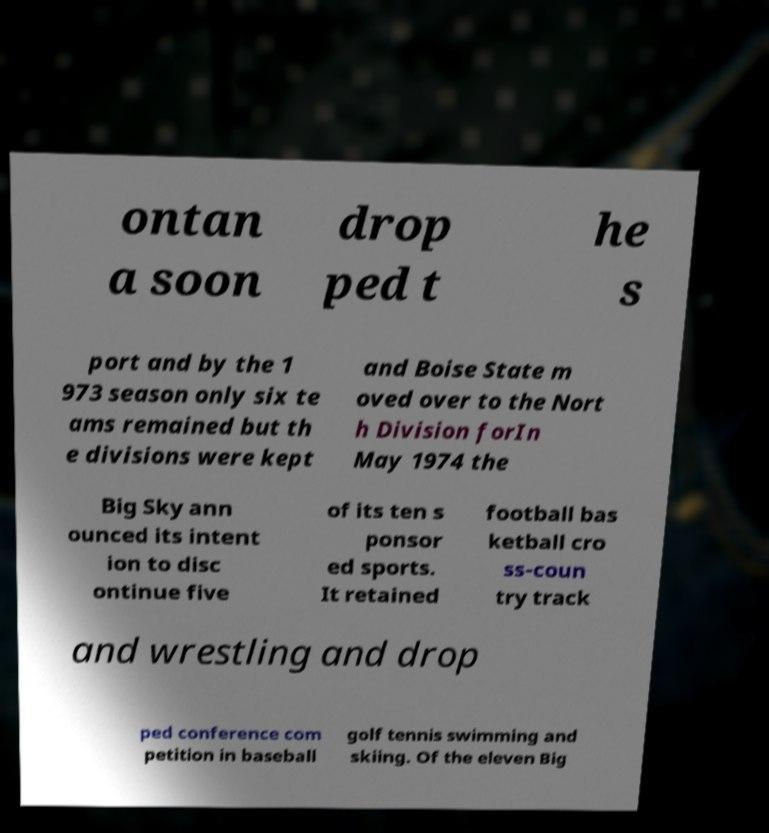For documentation purposes, I need the text within this image transcribed. Could you provide that? ontan a soon drop ped t he s port and by the 1 973 season only six te ams remained but th e divisions were kept and Boise State m oved over to the Nort h Division forIn May 1974 the Big Sky ann ounced its intent ion to disc ontinue five of its ten s ponsor ed sports. It retained football bas ketball cro ss-coun try track and wrestling and drop ped conference com petition in baseball golf tennis swimming and skiing. Of the eleven Big 